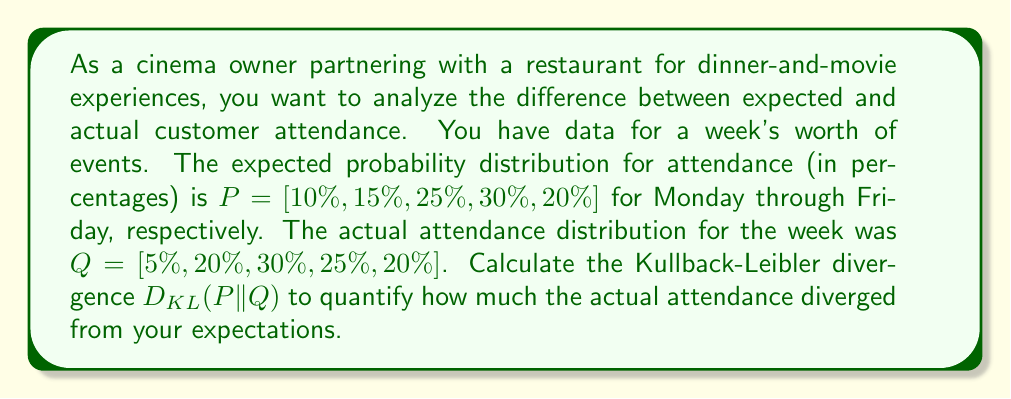Show me your answer to this math problem. To calculate the Kullback-Leibler divergence between the expected distribution P and the actual distribution Q, we use the formula:

$$D_{KL}(P||Q) = \sum_{i} P(i) \log\left(\frac{P(i)}{Q(i)}\right)$$

Where $P(i)$ and $Q(i)$ are the probabilities for each day i.

Let's calculate this step by step:

1) For Monday (i = 1):
   $P(1) = 0.10, Q(1) = 0.05$
   $0.10 \log\left(\frac{0.10}{0.05}\right) = 0.10 \log(2) \approx 0.0301$

2) For Tuesday (i = 2):
   $P(2) = 0.15, Q(2) = 0.20$
   $0.15 \log\left(\frac{0.15}{0.20}\right) \approx -0.0097$

3) For Wednesday (i = 3):
   $P(3) = 0.25, Q(3) = 0.30$
   $0.25 \log\left(\frac{0.25}{0.30}\right) \approx -0.0105$

4) For Thursday (i = 4):
   $P(4) = 0.30, Q(4) = 0.25$
   $0.30 \log\left(\frac{0.30}{0.25}\right) \approx 0.0125$

5) For Friday (i = 5):
   $P(5) = 0.20, Q(5) = 0.20$
   $0.20 \log\left(\frac{0.20}{0.20}\right) = 0$

Now, we sum all these values:

$$D_{KL}(P||Q) = 0.0301 + (-0.0097) + (-0.0105) + 0.0125 + 0 \approx 0.0224$$
Answer: The Kullback-Leibler divergence $D_{KL}(P||Q)$ between the expected and actual customer attendance distributions is approximately 0.0224. 